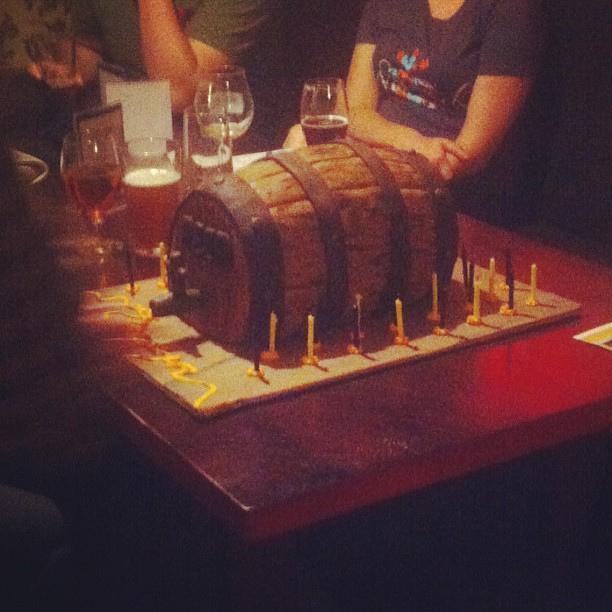Does the description: "The cake is at the edge of the dining table." accurately reflect the image?
Answer yes or no. No. 